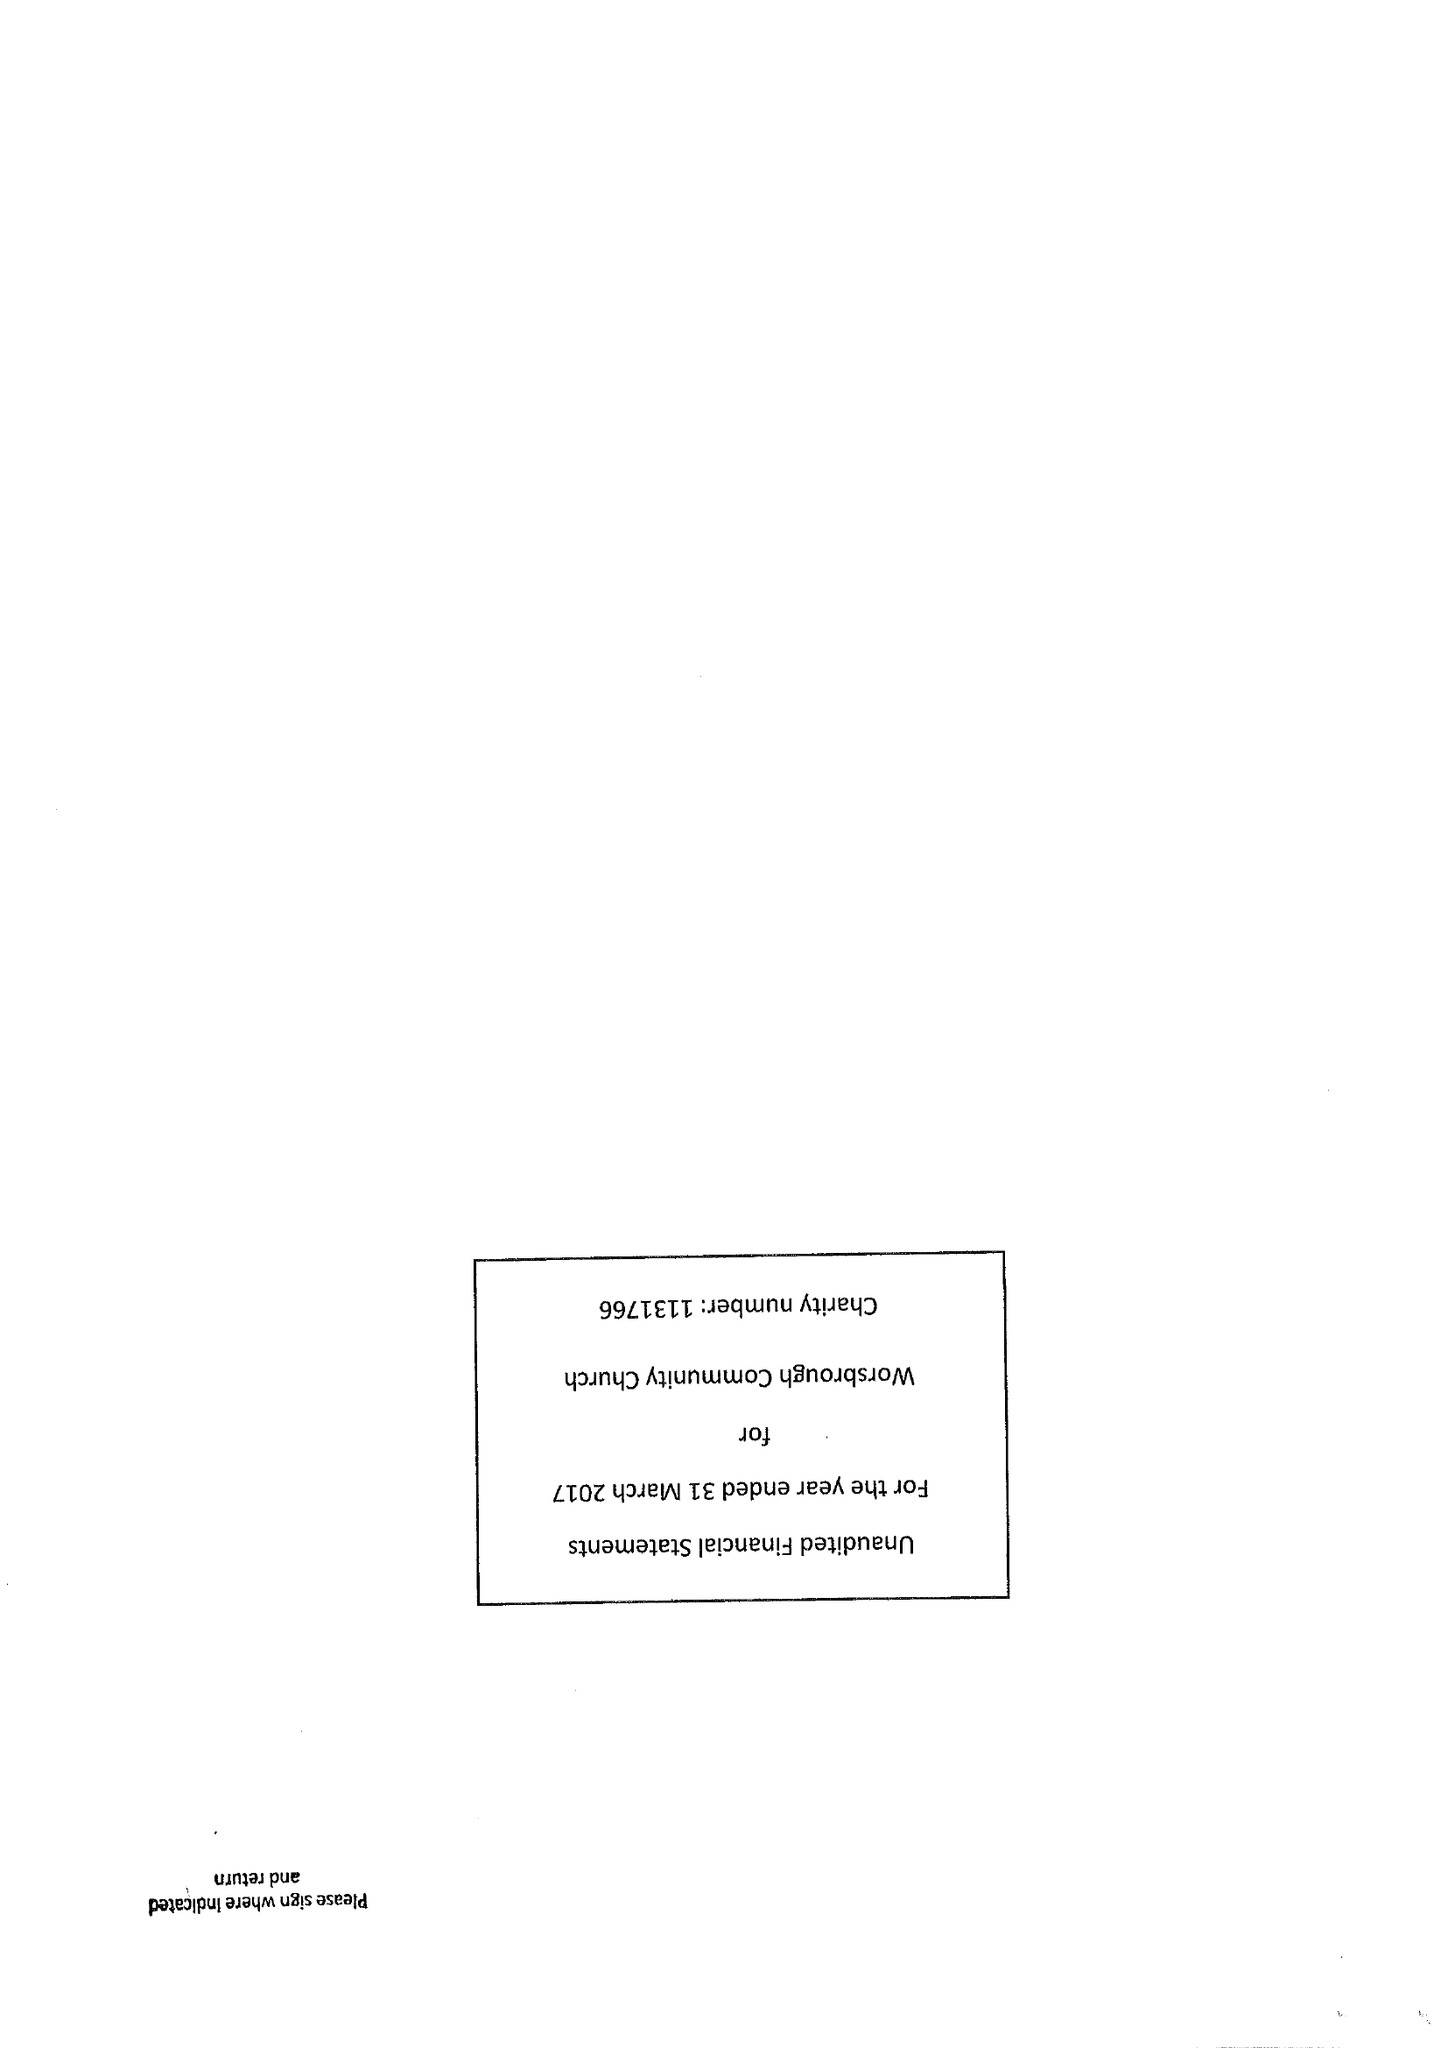What is the value for the report_date?
Answer the question using a single word or phrase. 2017-03-31 